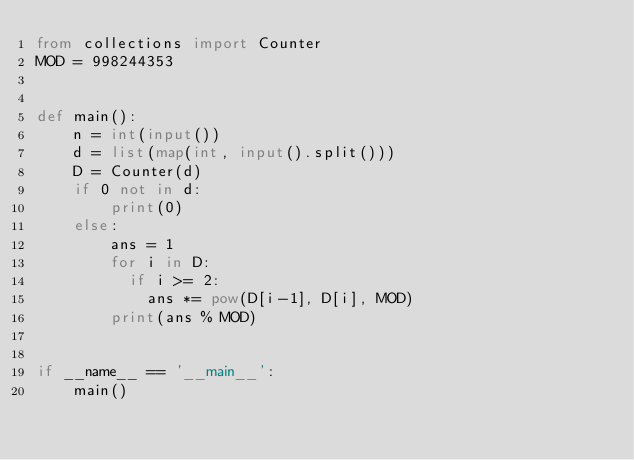<code> <loc_0><loc_0><loc_500><loc_500><_Python_>from collections import Counter
MOD = 998244353


def main():
    n = int(input())
    d = list(map(int, input().split()))
    D = Counter(d)
    if 0 not in d:
        print(0)
    else:
        ans = 1
        for i in D:
          if i >= 2:
            ans *= pow(D[i-1], D[i], MOD)
        print(ans % MOD)


if __name__ == '__main__':
    main()
</code> 